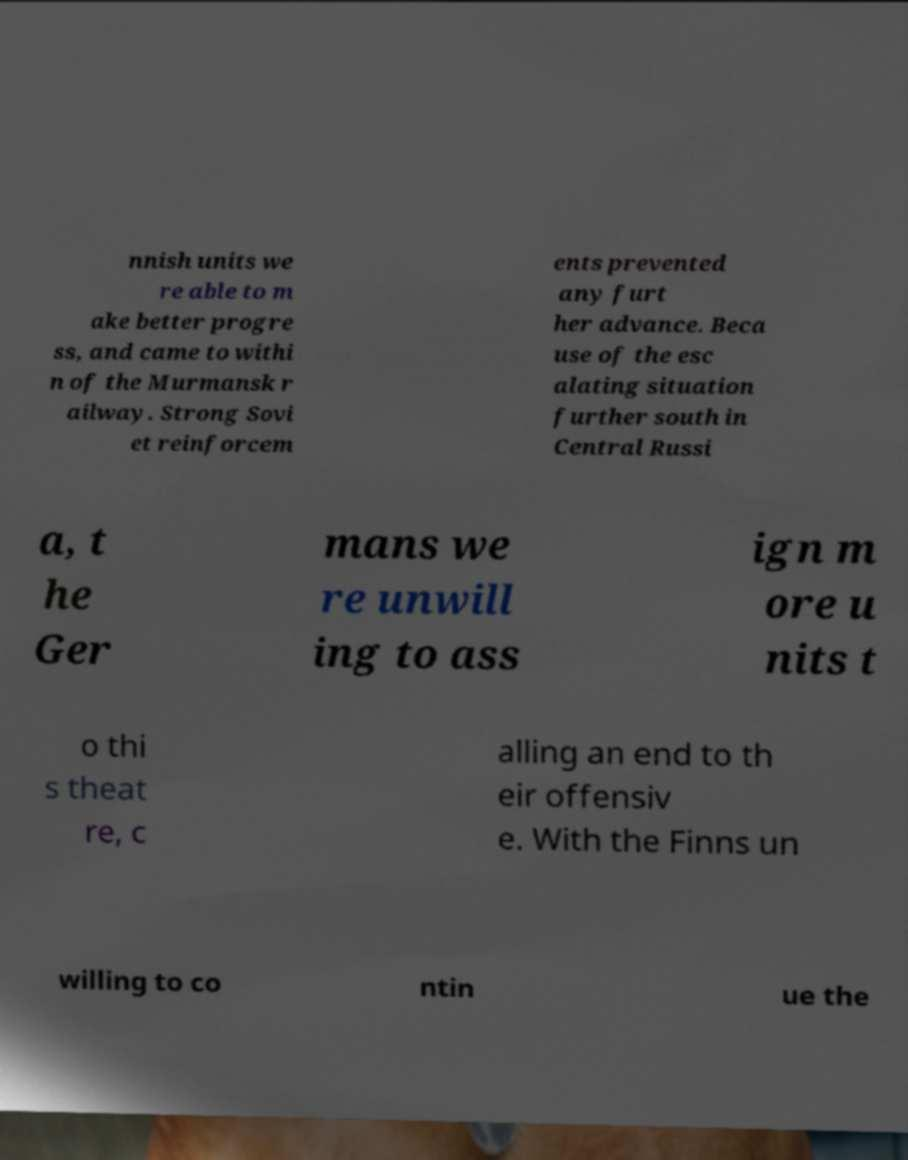I need the written content from this picture converted into text. Can you do that? nnish units we re able to m ake better progre ss, and came to withi n of the Murmansk r ailway. Strong Sovi et reinforcem ents prevented any furt her advance. Beca use of the esc alating situation further south in Central Russi a, t he Ger mans we re unwill ing to ass ign m ore u nits t o thi s theat re, c alling an end to th eir offensiv e. With the Finns un willing to co ntin ue the 